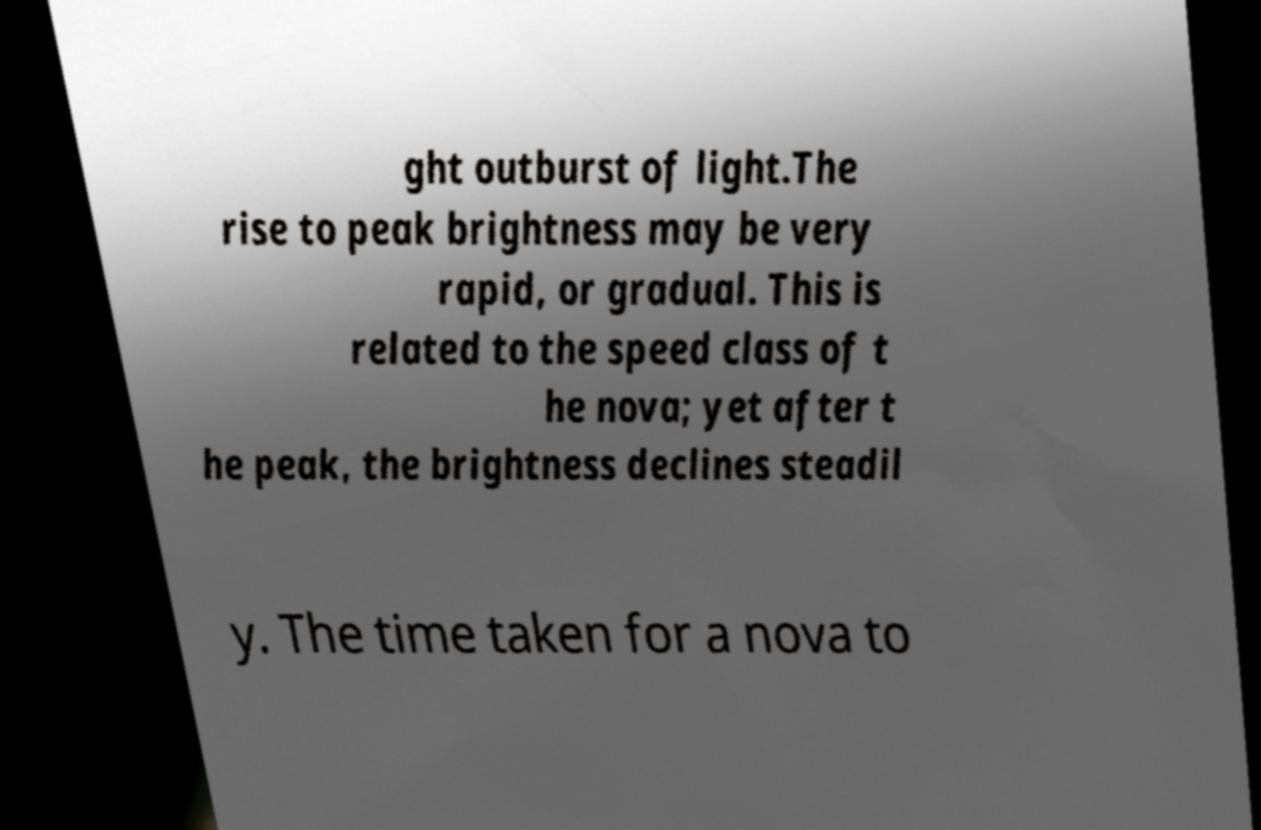There's text embedded in this image that I need extracted. Can you transcribe it verbatim? ght outburst of light.The rise to peak brightness may be very rapid, or gradual. This is related to the speed class of t he nova; yet after t he peak, the brightness declines steadil y. The time taken for a nova to 